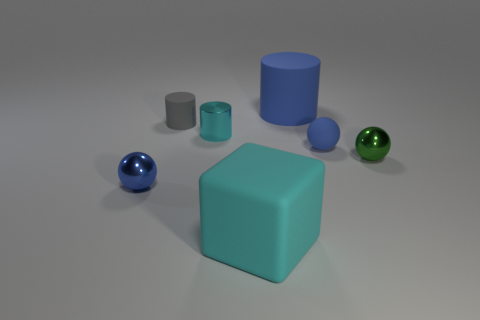How big is the blue rubber thing that is behind the small blue thing that is to the right of the small cyan metallic thing?
Keep it short and to the point. Large. There is a cyan object that is the same shape as the large blue object; what is it made of?
Your answer should be very brief. Metal. There is a big thing that is behind the green thing; is it the same shape as the big matte object left of the big blue matte cylinder?
Provide a succinct answer. No. Is the number of small matte things greater than the number of green objects?
Your response must be concise. Yes. The cyan matte cube is what size?
Keep it short and to the point. Large. What number of other things are the same color as the big rubber cylinder?
Make the answer very short. 2. Does the cyan object that is in front of the tiny cyan metal cylinder have the same material as the cyan cylinder?
Ensure brevity in your answer.  No. Is the number of small cyan metallic objects that are to the right of the small cyan metallic cylinder less than the number of gray things that are behind the small blue matte thing?
Provide a succinct answer. Yes. How many other things are there of the same material as the cyan block?
Ensure brevity in your answer.  3. There is a cyan object that is the same size as the blue metallic object; what material is it?
Make the answer very short. Metal. 